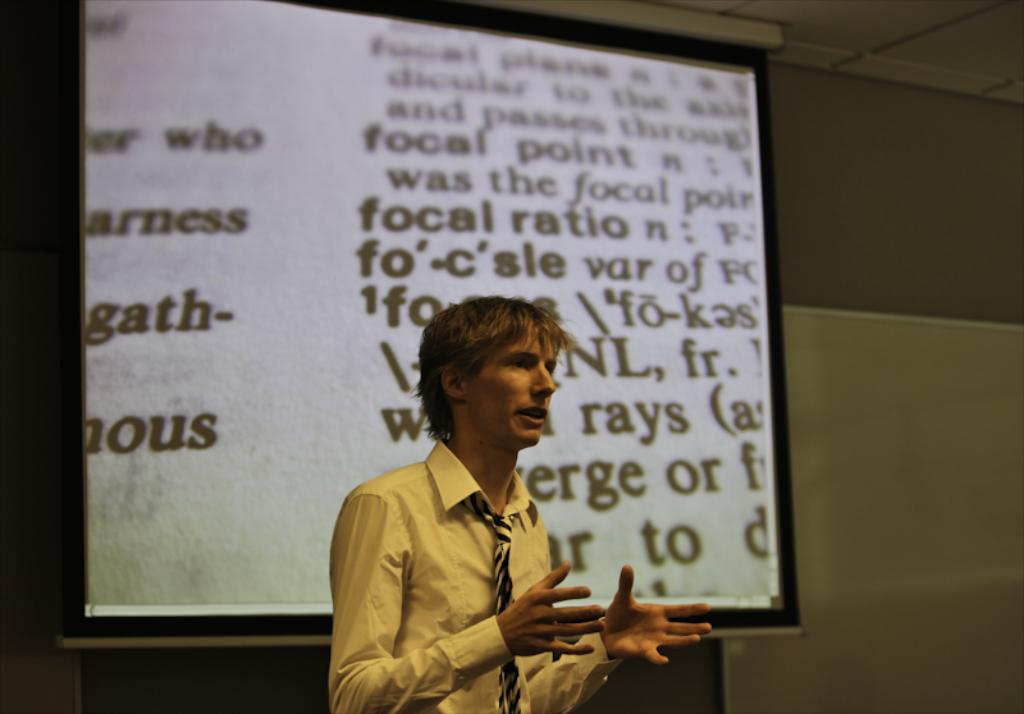What is the man in the image doing? The man is standing and talking in the image. What can be seen in the background of the image? There is a screen and a wall in the background of the image. What is the weight of the sink in the image? There is no sink present in the image, so it is not possible to determine its weight. 